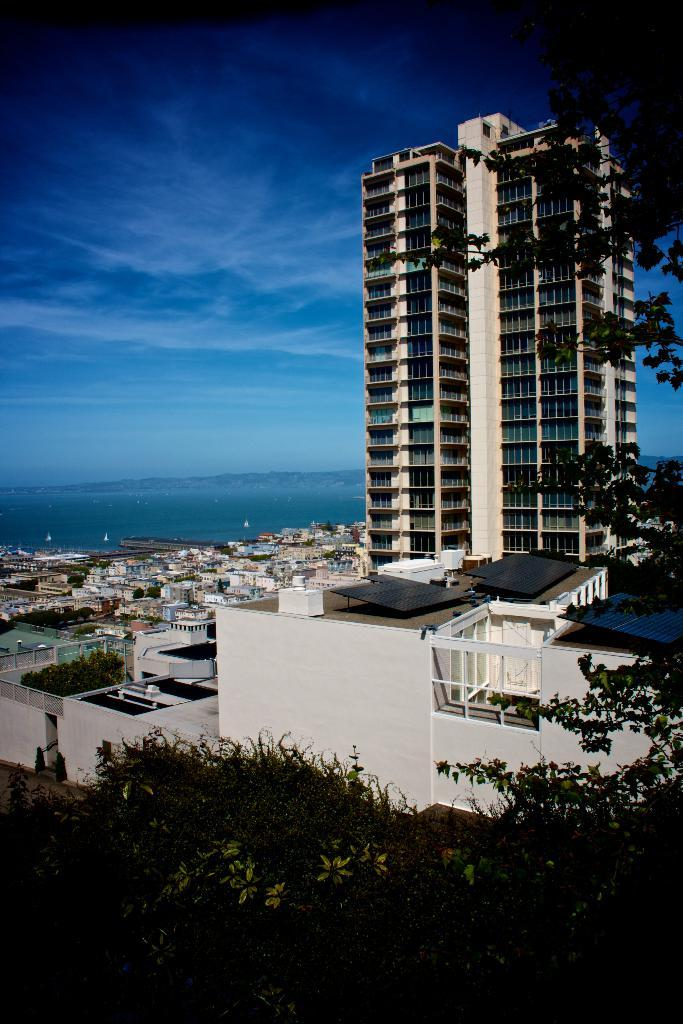What type of structures can be seen in the image? There are buildings in the image. What type of vegetation is present in the image? There are trees in the image. Can you see a zebra walking among the buildings in the image? No, there is no zebra present in the image. Is there any steam coming out of the buildings in the image? No, there is no steam visible in the image. 